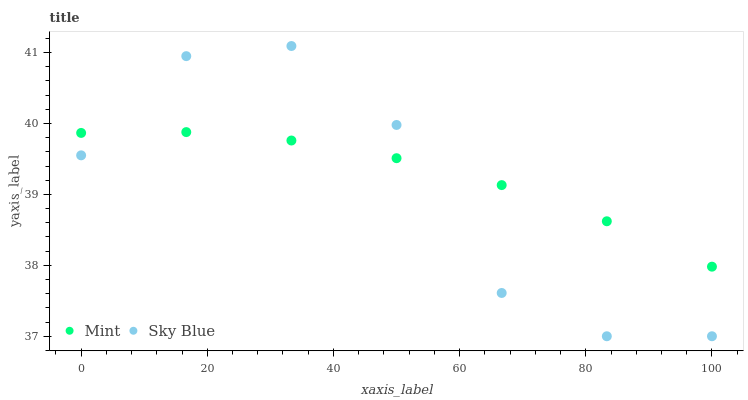Does Sky Blue have the minimum area under the curve?
Answer yes or no. Yes. Does Mint have the maximum area under the curve?
Answer yes or no. Yes. Does Mint have the minimum area under the curve?
Answer yes or no. No. Is Mint the smoothest?
Answer yes or no. Yes. Is Sky Blue the roughest?
Answer yes or no. Yes. Is Mint the roughest?
Answer yes or no. No. Does Sky Blue have the lowest value?
Answer yes or no. Yes. Does Mint have the lowest value?
Answer yes or no. No. Does Sky Blue have the highest value?
Answer yes or no. Yes. Does Mint have the highest value?
Answer yes or no. No. Does Sky Blue intersect Mint?
Answer yes or no. Yes. Is Sky Blue less than Mint?
Answer yes or no. No. Is Sky Blue greater than Mint?
Answer yes or no. No. 